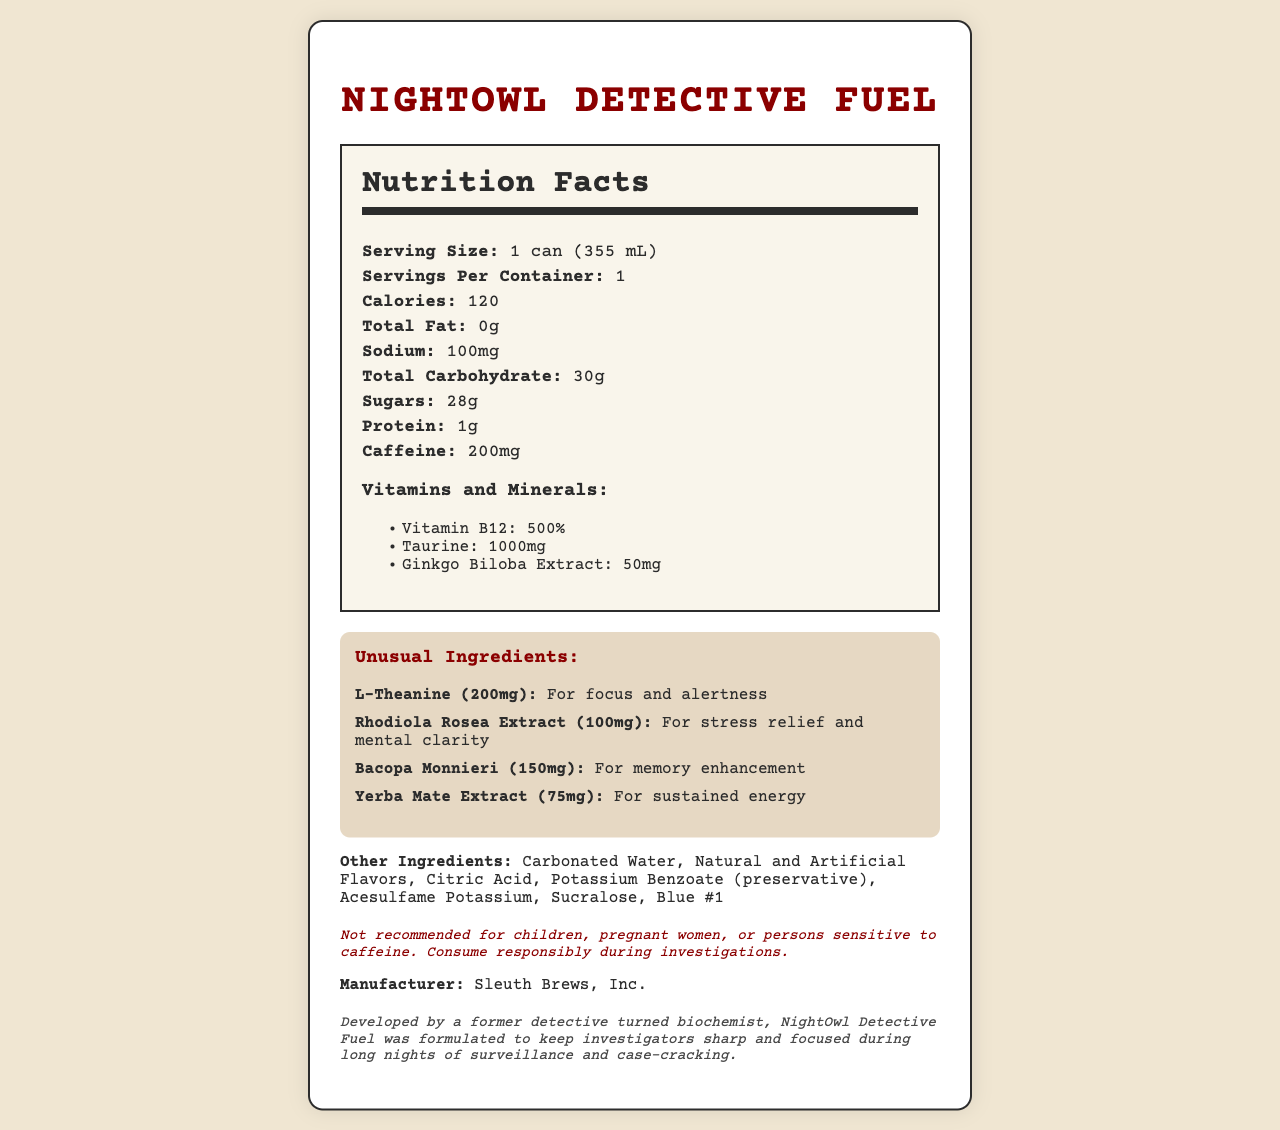what is the product name? The product name is prominently displayed at the top of the document in the title section.
Answer: NightOwl Detective Fuel how many servings are in a container? According to the Nutrition Facts section, there is 1 serving per container.
Answer: 1 what is the serving size? The serving size is indicated as "1 can (355 mL)" in the Nutrition Facts section.
Answer: 1 can (355 mL) how many calories are in a serving? The Nutrition Facts section lists the calorie count as 120.
Answer: 120 how much caffeine is in one serving? The amount of caffeine per serving is listed under the Nutrition Facts section as 200mg.
Answer: 200mg which vitamin or mineral is present at the highest percentage of daily value? A. Taurine B. Vitamin B12 C. Ginkgo Biloba Extract D. L-Theanine The document shows that Vitamin B12 is present at 500%, which is higher than the amounts given for Taurine (1000mg) and Ginkgo Biloba Extract (50mg).
Answer: B. Vitamin B12 what are the purposes of the unusual ingredients? The document details the purposes of unusual ingredients with each of their names and specific functions.
Answer: For focus and alertness, stress relief and mental clarity, memory enhancement, and sustained energy which unusual ingredient is used for memory enhancement? A. L-Theanine B. Rhodiola Rosea Extract C. Bacopa Monnieri D. Yerba Mate Extract Bacopa Monnieri is listed with the purpose "For memory enhancement".
Answer: C. Bacopa Monnieri does the energy drink contain any sodium? The Nutrition Facts section lists that the drink contains 100mg of sodium.
Answer: Yes summarize the document. The document provides a comprehensive view of the nutritional content, unusual ingredients with their purposes, and a fictional backstory about the product.
Answer: A fictional energy drink called "NightOwl Detective Fuel" contains various ingredients to boost focus, memory, and energy, designed especially for detectives. is this drink recommended for children? The disclaimer at the bottom clearly states that the drink is not recommended for children, pregnant women, or persons sensitive to caffeine.
Answer: No what is the fictional backstory of the product? The fictional backstory explains that it was formulated by a former detective turned biochemist to help investigators during long nights.
Answer: Developed by a former detective turned biochemist to keep investigators sharp and focused. who is the manufacturer of the drink? The document lists the manufacturer as Sleuth Brews, Inc.
Answer: Sleuth Brews, Inc. how much total carbohydrate does the energy drink contain? The Nutrition Facts section mentions that the total carbohydrate content is 30g per serving.
Answer: 30g what ingredient gives the drink its blue color? The document lists "Blue #1" under the other ingredients section.
Answer: Blue #1 how many grams of sugar are in the drink? The Nutrition Facts section states that the drink contains 28g of sugars.
Answer: 28g what kind of drink is "NightOwl Detective Fuel"? It is described as an energy drink consumed by a detective.
Answer: Energy drink how does the document describe the flavoring agents in the drink? The other ingredients section mentions both "Natural and Artificial Flavors".
Answer: Natural and Artificial Flavors which ingredient is used for sustained energy? The Yerba Mate Extract is listed under unusual ingredients with the purpose of providing sustained energy.
Answer: Yerba Mate Extract is the exact blend of natural and artificial flavors detailed in the document? The document lists "Natural and Artificial Flavors" but does not go into specific detail about them.
Answer: Not enough information 